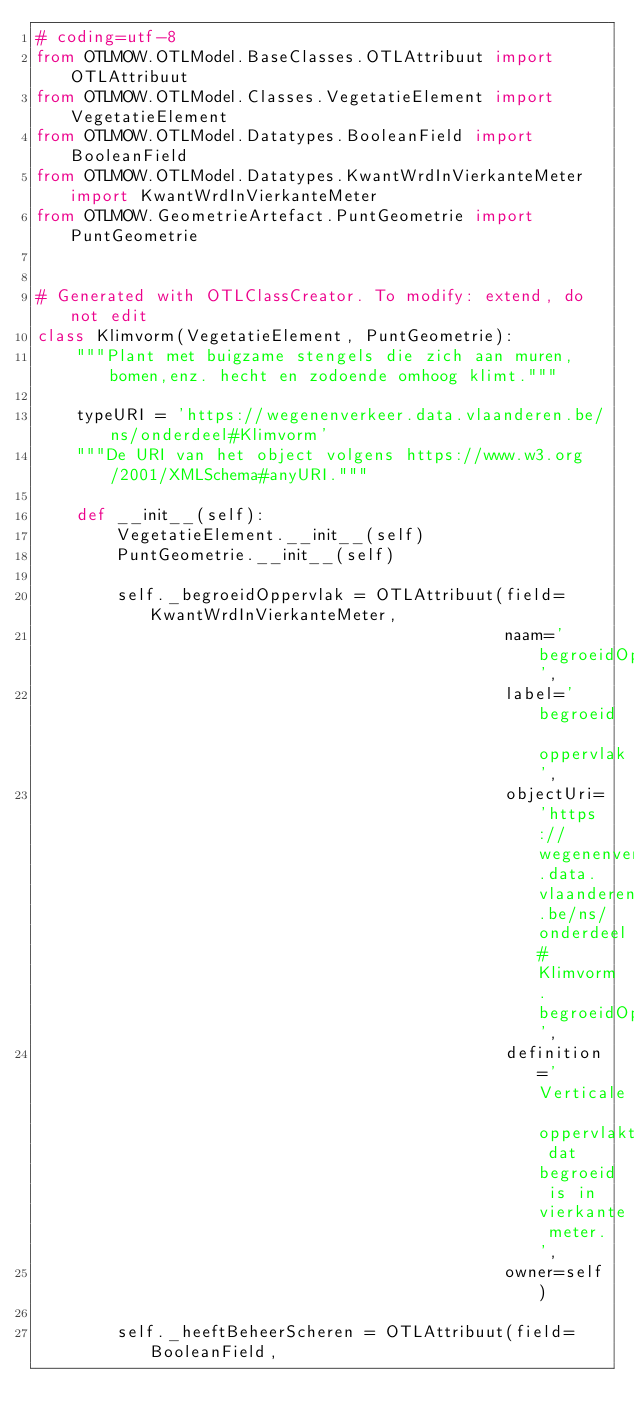Convert code to text. <code><loc_0><loc_0><loc_500><loc_500><_Python_># coding=utf-8
from OTLMOW.OTLModel.BaseClasses.OTLAttribuut import OTLAttribuut
from OTLMOW.OTLModel.Classes.VegetatieElement import VegetatieElement
from OTLMOW.OTLModel.Datatypes.BooleanField import BooleanField
from OTLMOW.OTLModel.Datatypes.KwantWrdInVierkanteMeter import KwantWrdInVierkanteMeter
from OTLMOW.GeometrieArtefact.PuntGeometrie import PuntGeometrie


# Generated with OTLClassCreator. To modify: extend, do not edit
class Klimvorm(VegetatieElement, PuntGeometrie):
    """Plant met buigzame stengels die zich aan muren,bomen,enz. hecht en zodoende omhoog klimt."""

    typeURI = 'https://wegenenverkeer.data.vlaanderen.be/ns/onderdeel#Klimvorm'
    """De URI van het object volgens https://www.w3.org/2001/XMLSchema#anyURI."""

    def __init__(self):
        VegetatieElement.__init__(self)
        PuntGeometrie.__init__(self)

        self._begroeidOppervlak = OTLAttribuut(field=KwantWrdInVierkanteMeter,
                                               naam='begroeidOppervlak',
                                               label='begroeid oppervlak',
                                               objectUri='https://wegenenverkeer.data.vlaanderen.be/ns/onderdeel#Klimvorm.begroeidOppervlak',
                                               definition='Verticale oppervlakte dat begroeid is in vierkante meter.',
                                               owner=self)

        self._heeftBeheerScheren = OTLAttribuut(field=BooleanField,</code> 